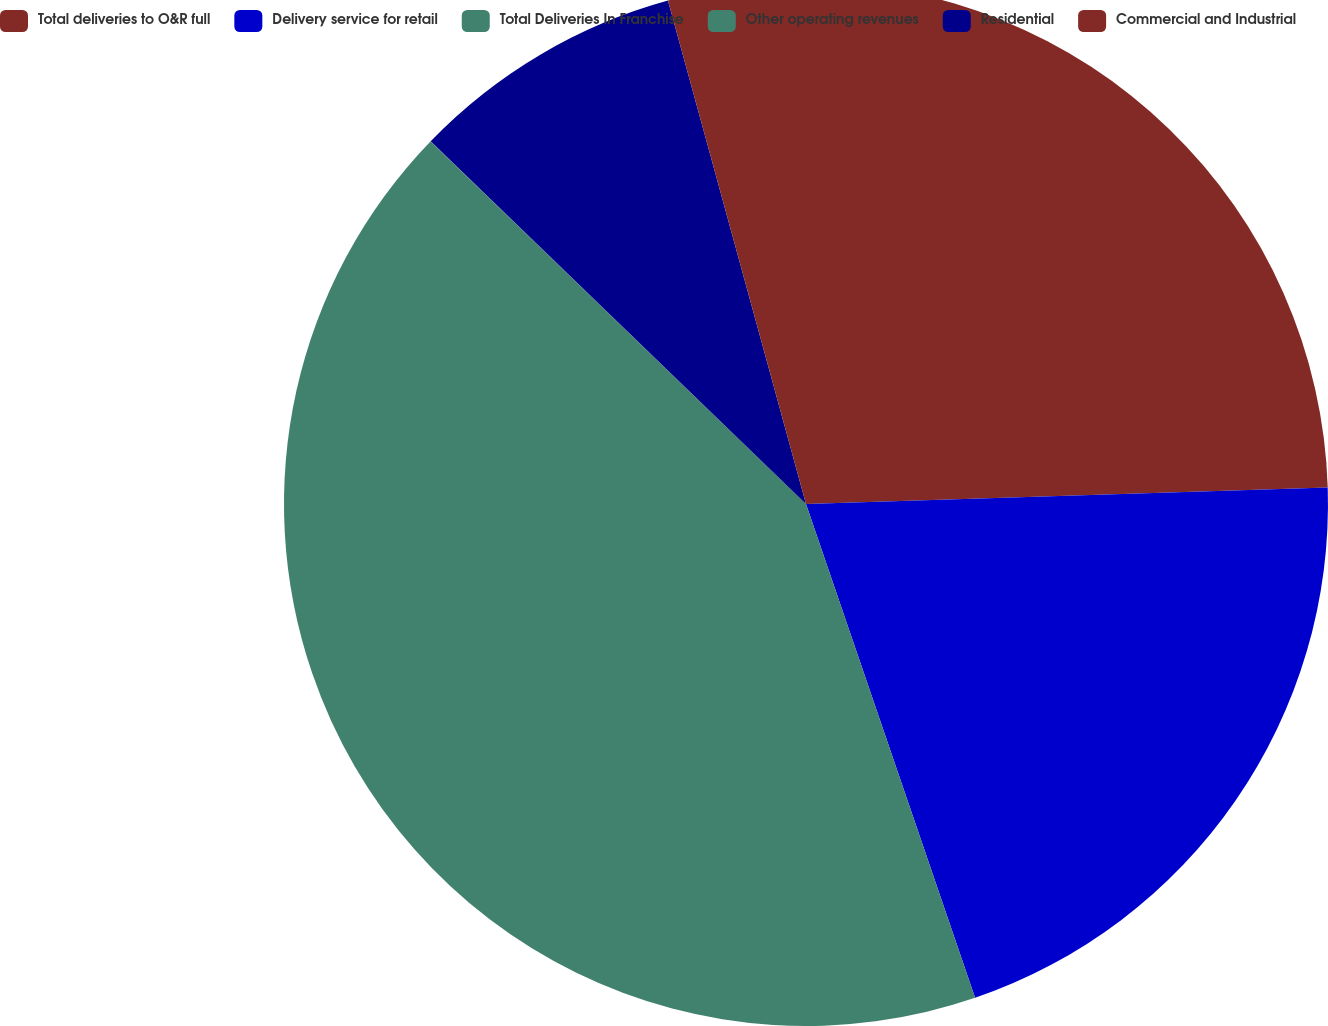Convert chart. <chart><loc_0><loc_0><loc_500><loc_500><pie_chart><fcel>Total deliveries to O&R full<fcel>Delivery service for retail<fcel>Total Deliveries In Franchise<fcel>Other operating revenues<fcel>Residential<fcel>Commercial and Industrial<nl><fcel>24.5%<fcel>20.25%<fcel>42.47%<fcel>0.01%<fcel>8.51%<fcel>4.26%<nl></chart> 